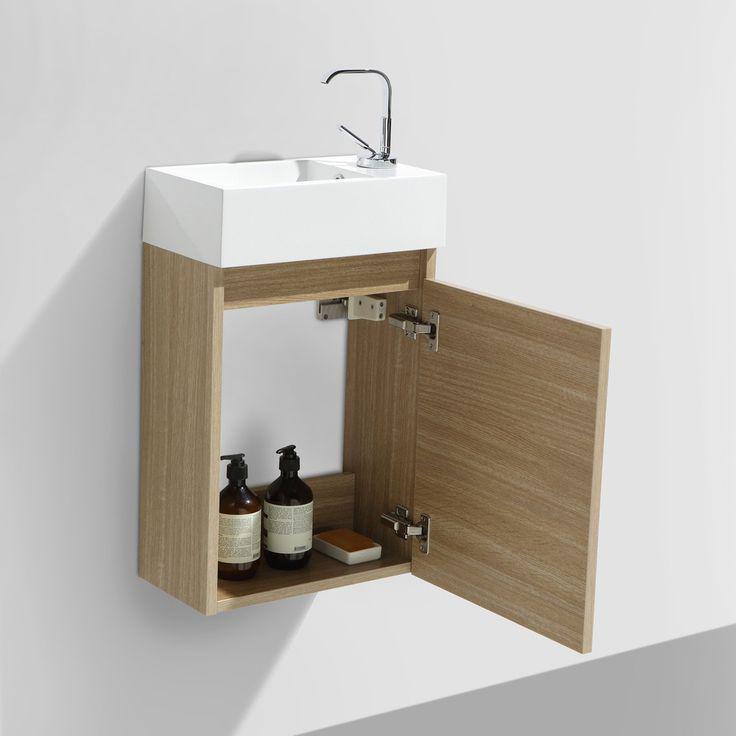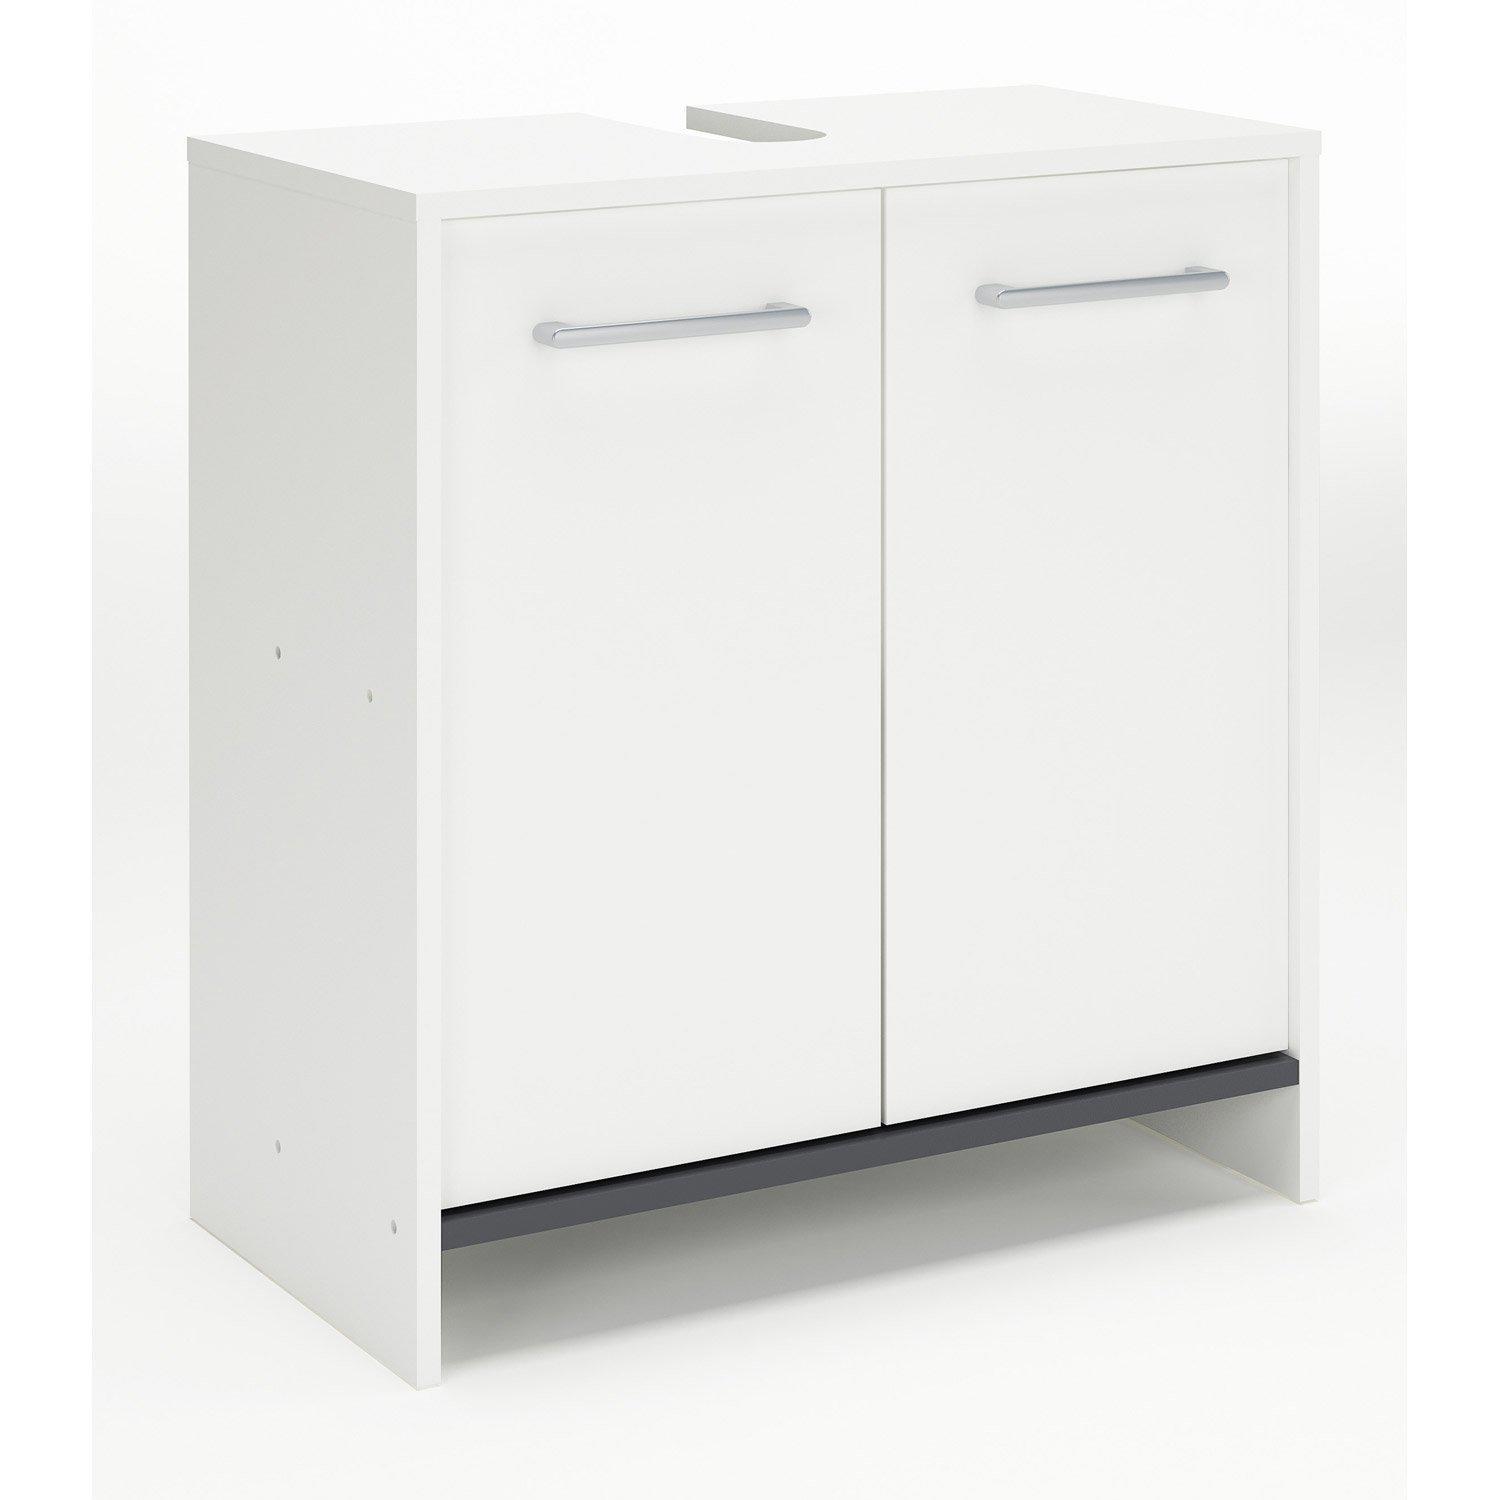The first image is the image on the left, the second image is the image on the right. Given the left and right images, does the statement "The left image features a white rectangular wall-mounted sink with its spout on the right side and a box shape underneath that does not extend to the floor." hold true? Answer yes or no. Yes. The first image is the image on the left, the second image is the image on the right. For the images shown, is this caption "The door on one of the cabinets is open." true? Answer yes or no. Yes. 